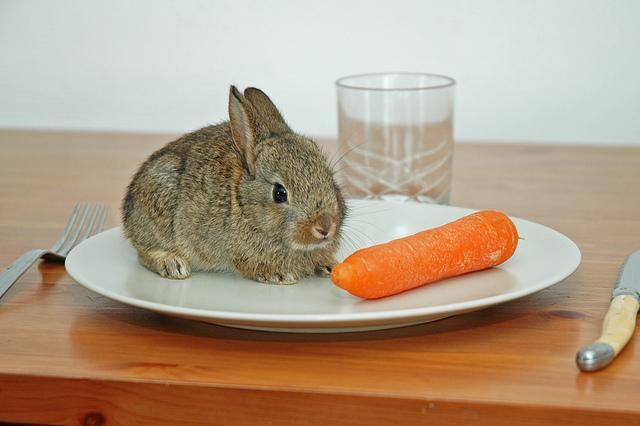What is the rabbit doing on the plate?
Select the accurate answer and provide justification: `Answer: choice
Rationale: srationale.`
Options: Mating, playing, sleeping, eating carrot. Answer: eating carrot.
Rationale: The rabbit is placed next to a carrot and is an animal well known for eating carrots. 